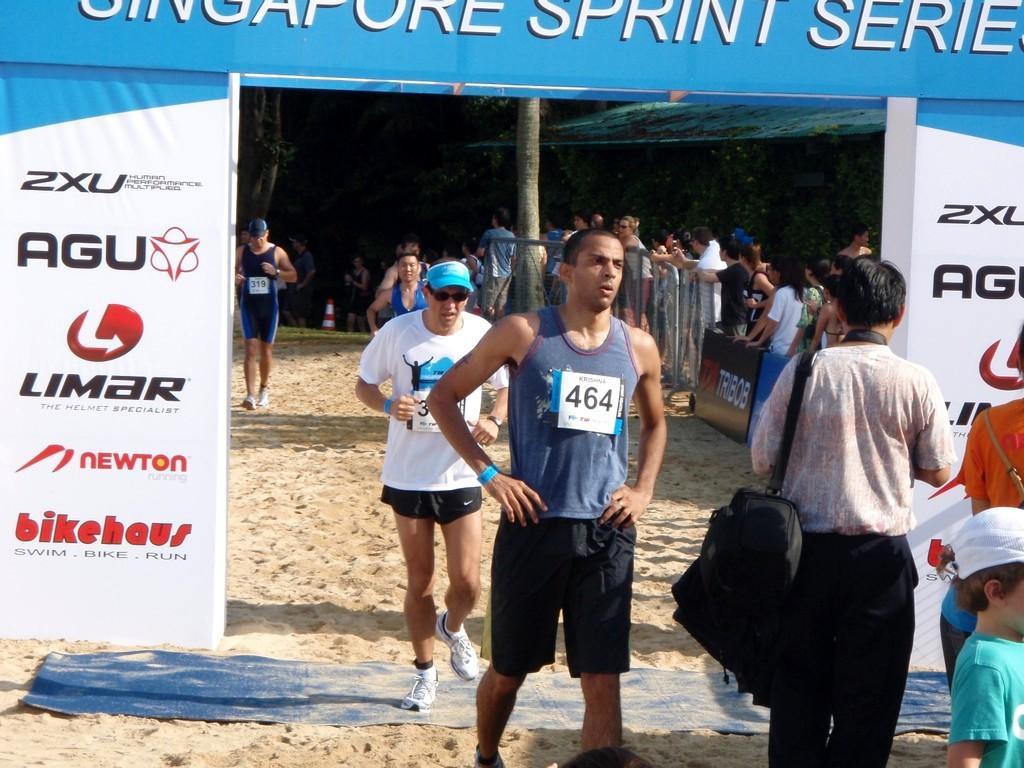In one or two sentences, can you explain what this image depicts? In the center of the image there are people. There is a banner. At the bottom of the there is sand. There is a safety cone. 